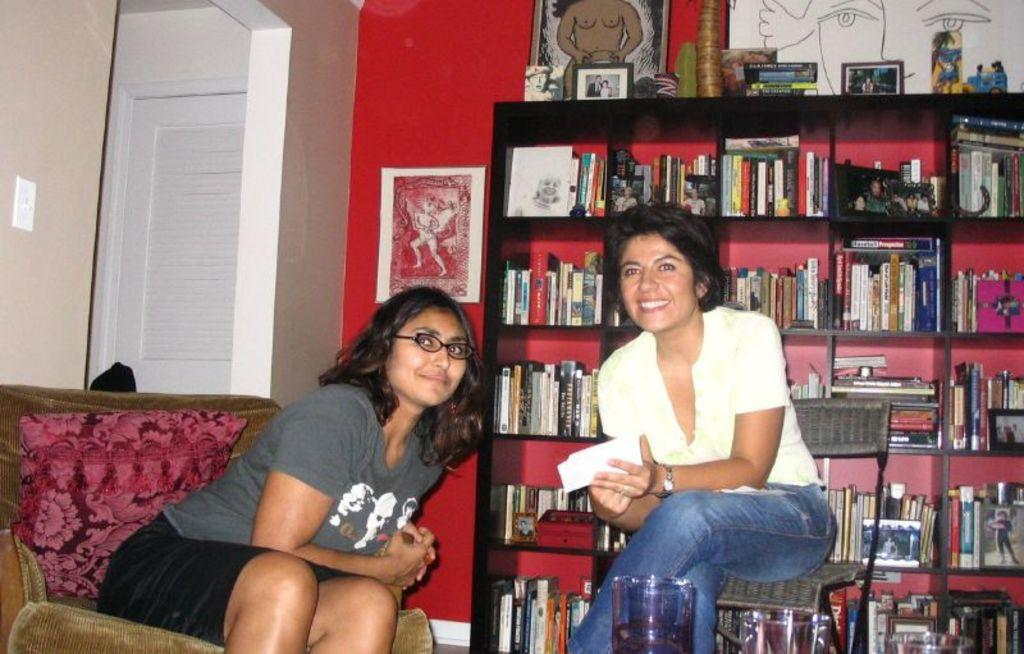How many women are present in the image? There are two women in the image. What are the women doing in the image? The women are sitting on chairs. What can be seen in the background of the image? There are books, posters, and a wall in the background of the image. What type of bun is being served at the feast in the image? There is no feast or bun present in the image; it features two women sitting on chairs with a background containing books, posters, and a wall. 